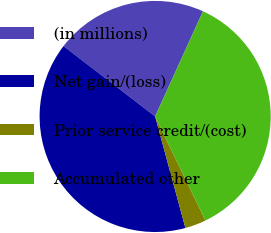Convert chart to OTSL. <chart><loc_0><loc_0><loc_500><loc_500><pie_chart><fcel>(in millions)<fcel>Net gain/(loss)<fcel>Prior service credit/(cost)<fcel>Accumulated other<nl><fcel>21.37%<fcel>39.64%<fcel>2.95%<fcel>36.04%<nl></chart> 